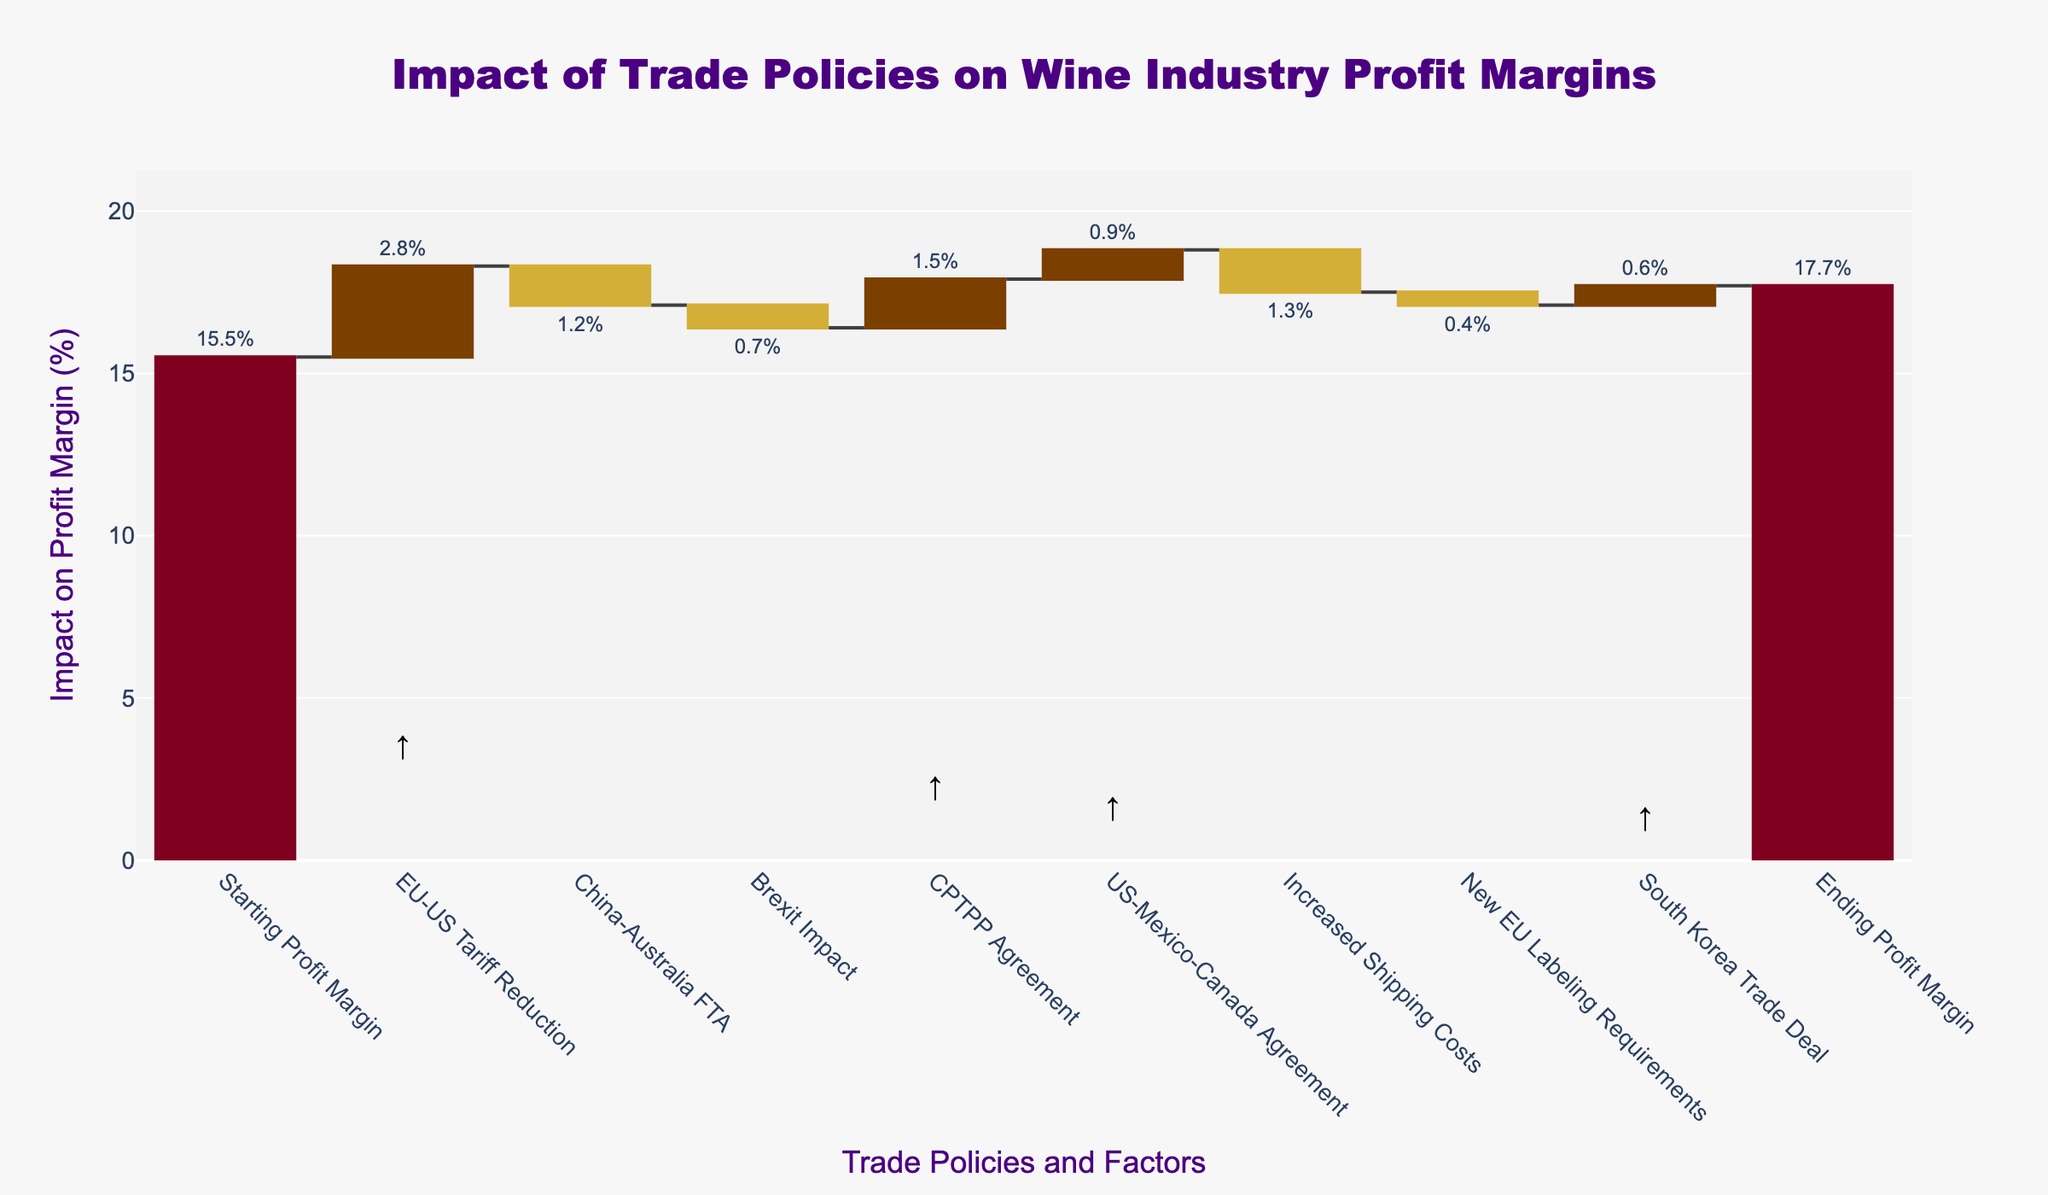What's the title of the figure? The title of the figure is displayed prominently at the top and reads "Impact of Trade Policies on Wine Industry Profit Margins".
Answer: Impact of Trade Policies on Wine Industry Profit Margins What is the starting profit margin? The starting profit margin is the first data point listed in the chart, which is labeled "Starting Profit Margin" with an impact value of 15.5%.
Answer: 15.5% Which trade policy had the most positive impact on profit margins? Among the trade policies shown, the "EU-US Tariff Reduction" had the highest positive impact, indicated by the largest upward bar and a text label showing an impact of 2.8%.
Answer: EU-US Tariff Reduction What is the ending profit margin? The ending profit margin is the last data point on the chart labeled "Ending Profit Margin" and shows an impact value of 17.7%.
Answer: 17.7% How did the 'China-Australia FTA' impact the profit margins? The 'China-Australia FTA' is shown as a negative impact in the chart, contributing to a decrease and is indicated with a downward bar with a text label of -1.2%.
Answer: -1.2% What is the total increase in profit margins from "US-Mexico-Canada Agreement" and "South Korea Trade Deal"? Both policies had positive impacts. The "US-Mexico-Canada Agreement" added 0.9% and the "South Korea Trade Deal" added 0.6%. Summing these values gives 0.9% + 0.6% = 1.5%.
Answer: 1.5% Which policy contributed a 1.5% increase in profit margins and when is it indicated in the chart? The "CPTPP Agreement" contributed a 1.5% increase in profit margins, shown as an upward bar in the middle of the chart with a label of 1.5%.
Answer: CPTPP Agreement What is the net impact of "Increased Shipping Costs" and "Brexit Impact" on the profit margins? Both have negative impacts. "Increased Shipping Costs" contributed -1.3% and "Brexit Impact" contributed -0.7%. Summing these values gives -1.3% + -0.7% = -2.0%.
Answer: -2.0% How do the impacts of "New EU Labeling Requirements" and "Brexit Impact" compare? Both have negative impacts shown as downward bars. The "New EU Labeling Requirements" have a smaller negative impact (-0.4%) compared to "Brexit Impact" (-0.7%).
Answer: Brexit Impact is greater than New EU Labeling Requirements What would the ending profit margin be if the "EU-US Tariff Reduction" was not implemented? The "EU-US Tariff Reduction" positively impacted profit margin by 2.8%. To find the ending profit margin without this policy, subtract 2.8% from the actual ending profit margin (17.7%), giving 17.7% - 2.8% = 14.9%.
Answer: 14.9% 